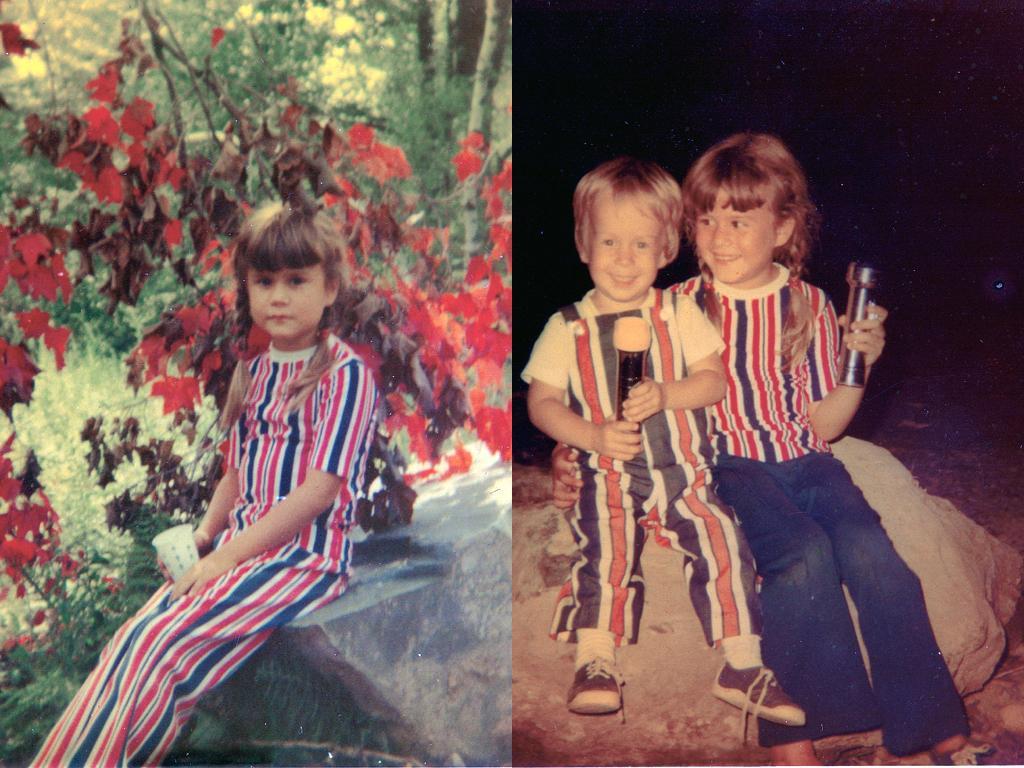Please provide a concise description of this image. In the picture we can see two images, in the first image we can see a girl child sitting on the rock surface and behind her we can see some maple leaf plant and behind it, we can see some trees and in the second image we can see the girl and boy sitting on the rock surface and holding something in their hands. 